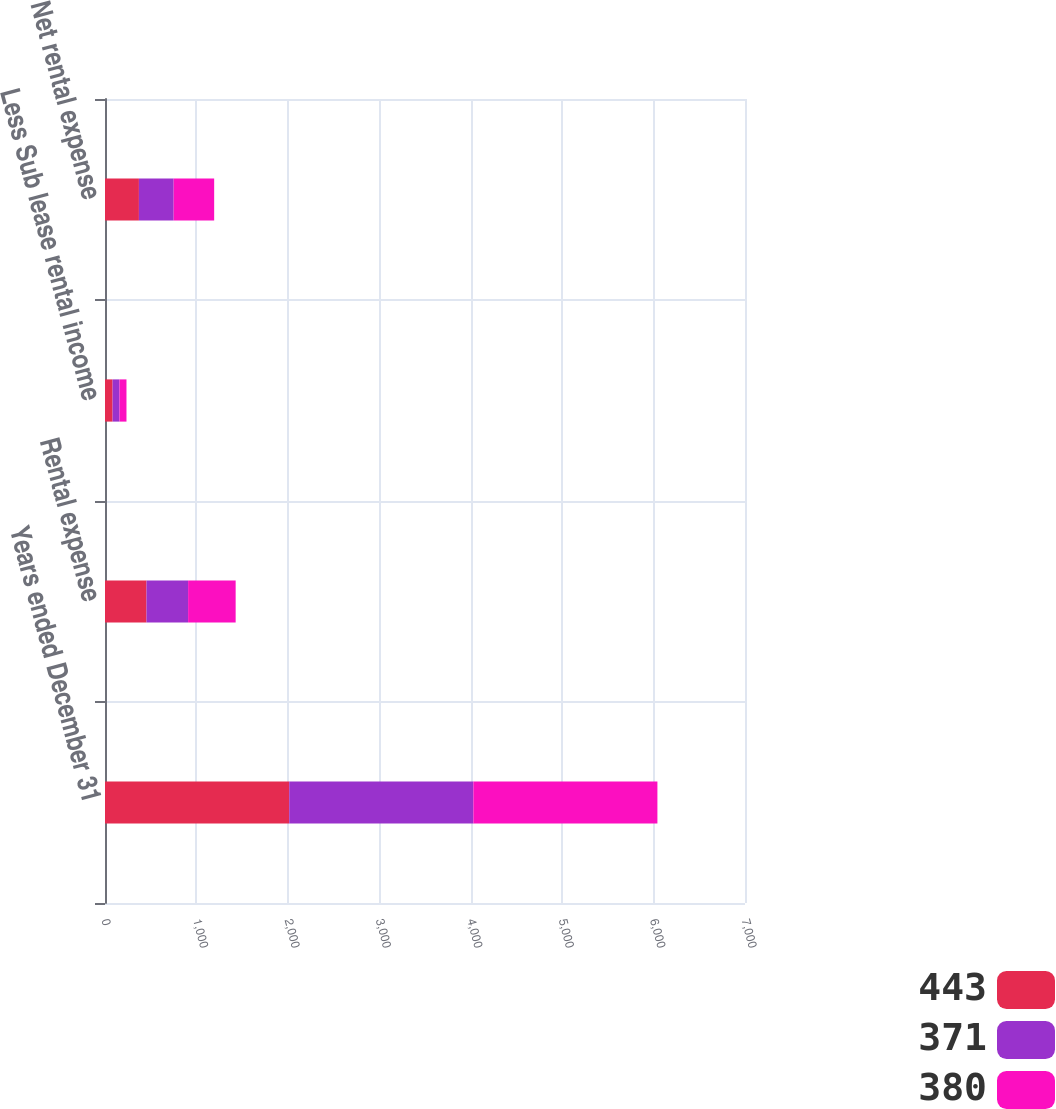Convert chart. <chart><loc_0><loc_0><loc_500><loc_500><stacked_bar_chart><ecel><fcel>Years ended December 31<fcel>Rental expense<fcel>Less Sub lease rental income<fcel>Net rental expense<nl><fcel>443<fcel>2015<fcel>454<fcel>83<fcel>371<nl><fcel>371<fcel>2014<fcel>455<fcel>75<fcel>380<nl><fcel>380<fcel>2013<fcel>520<fcel>77<fcel>443<nl></chart> 